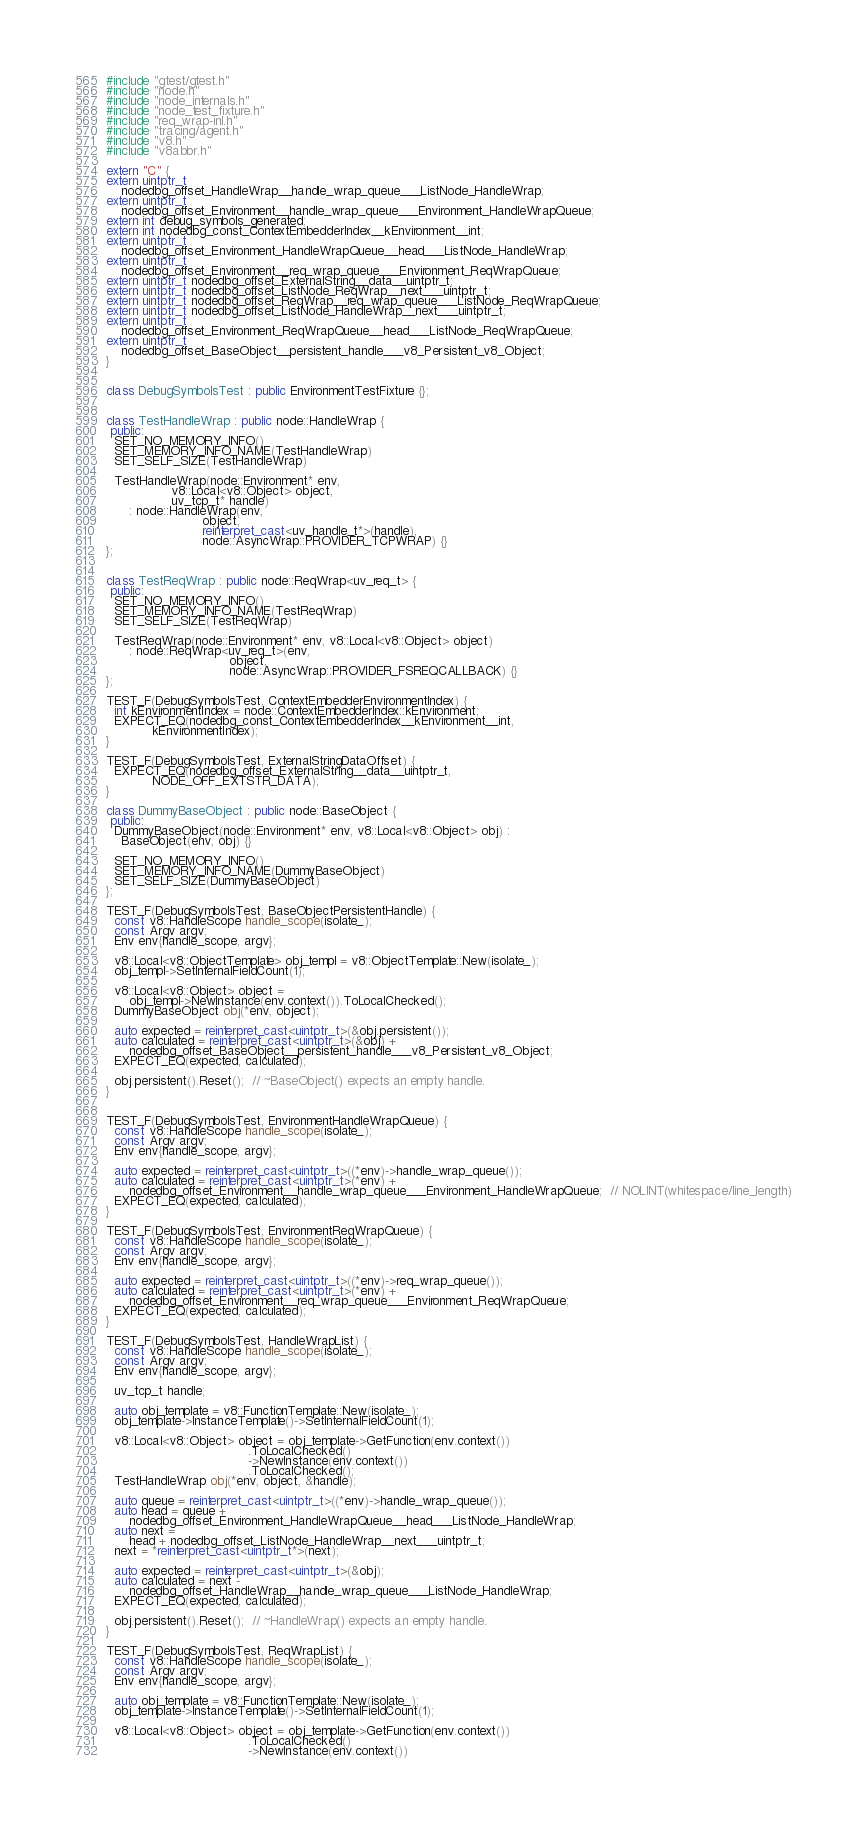Convert code to text. <code><loc_0><loc_0><loc_500><loc_500><_C++_>#include "gtest/gtest.h"
#include "node.h"
#include "node_internals.h"
#include "node_test_fixture.h"
#include "req_wrap-inl.h"
#include "tracing/agent.h"
#include "v8.h"
#include "v8abbr.h"

extern "C" {
extern uintptr_t
    nodedbg_offset_HandleWrap__handle_wrap_queue___ListNode_HandleWrap;
extern uintptr_t
    nodedbg_offset_Environment__handle_wrap_queue___Environment_HandleWrapQueue;
extern int debug_symbols_generated;
extern int nodedbg_const_ContextEmbedderIndex__kEnvironment__int;
extern uintptr_t
    nodedbg_offset_Environment_HandleWrapQueue__head___ListNode_HandleWrap;
extern uintptr_t
    nodedbg_offset_Environment__req_wrap_queue___Environment_ReqWrapQueue;
extern uintptr_t nodedbg_offset_ExternalString__data__uintptr_t;
extern uintptr_t nodedbg_offset_ListNode_ReqWrap__next___uintptr_t;
extern uintptr_t nodedbg_offset_ReqWrap__req_wrap_queue___ListNode_ReqWrapQueue;
extern uintptr_t nodedbg_offset_ListNode_HandleWrap__next___uintptr_t;
extern uintptr_t
    nodedbg_offset_Environment_ReqWrapQueue__head___ListNode_ReqWrapQueue;
extern uintptr_t
    nodedbg_offset_BaseObject__persistent_handle___v8_Persistent_v8_Object;
}


class DebugSymbolsTest : public EnvironmentTestFixture {};


class TestHandleWrap : public node::HandleWrap {
 public:
  SET_NO_MEMORY_INFO()
  SET_MEMORY_INFO_NAME(TestHandleWrap)
  SET_SELF_SIZE(TestHandleWrap)

  TestHandleWrap(node::Environment* env,
                 v8::Local<v8::Object> object,
                 uv_tcp_t* handle)
      : node::HandleWrap(env,
                         object,
                         reinterpret_cast<uv_handle_t*>(handle),
                         node::AsyncWrap::PROVIDER_TCPWRAP) {}
};


class TestReqWrap : public node::ReqWrap<uv_req_t> {
 public:
  SET_NO_MEMORY_INFO()
  SET_MEMORY_INFO_NAME(TestReqWrap)
  SET_SELF_SIZE(TestReqWrap)

  TestReqWrap(node::Environment* env, v8::Local<v8::Object> object)
      : node::ReqWrap<uv_req_t>(env,
                                object,
                                node::AsyncWrap::PROVIDER_FSREQCALLBACK) {}
};

TEST_F(DebugSymbolsTest, ContextEmbedderEnvironmentIndex) {
  int kEnvironmentIndex = node::ContextEmbedderIndex::kEnvironment;
  EXPECT_EQ(nodedbg_const_ContextEmbedderIndex__kEnvironment__int,
            kEnvironmentIndex);
}

TEST_F(DebugSymbolsTest, ExternalStringDataOffset) {
  EXPECT_EQ(nodedbg_offset_ExternalString__data__uintptr_t,
            NODE_OFF_EXTSTR_DATA);
}

class DummyBaseObject : public node::BaseObject {
 public:
  DummyBaseObject(node::Environment* env, v8::Local<v8::Object> obj) :
    BaseObject(env, obj) {}

  SET_NO_MEMORY_INFO()
  SET_MEMORY_INFO_NAME(DummyBaseObject)
  SET_SELF_SIZE(DummyBaseObject)
};

TEST_F(DebugSymbolsTest, BaseObjectPersistentHandle) {
  const v8::HandleScope handle_scope(isolate_);
  const Argv argv;
  Env env{handle_scope, argv};

  v8::Local<v8::ObjectTemplate> obj_templ = v8::ObjectTemplate::New(isolate_);
  obj_templ->SetInternalFieldCount(1);

  v8::Local<v8::Object> object =
      obj_templ->NewInstance(env.context()).ToLocalChecked();
  DummyBaseObject obj(*env, object);

  auto expected = reinterpret_cast<uintptr_t>(&obj.persistent());
  auto calculated = reinterpret_cast<uintptr_t>(&obj) +
      nodedbg_offset_BaseObject__persistent_handle___v8_Persistent_v8_Object;
  EXPECT_EQ(expected, calculated);

  obj.persistent().Reset();  // ~BaseObject() expects an empty handle.
}


TEST_F(DebugSymbolsTest, EnvironmentHandleWrapQueue) {
  const v8::HandleScope handle_scope(isolate_);
  const Argv argv;
  Env env{handle_scope, argv};

  auto expected = reinterpret_cast<uintptr_t>((*env)->handle_wrap_queue());
  auto calculated = reinterpret_cast<uintptr_t>(*env) +
      nodedbg_offset_Environment__handle_wrap_queue___Environment_HandleWrapQueue;  // NOLINT(whitespace/line_length)
  EXPECT_EQ(expected, calculated);
}

TEST_F(DebugSymbolsTest, EnvironmentReqWrapQueue) {
  const v8::HandleScope handle_scope(isolate_);
  const Argv argv;
  Env env{handle_scope, argv};

  auto expected = reinterpret_cast<uintptr_t>((*env)->req_wrap_queue());
  auto calculated = reinterpret_cast<uintptr_t>(*env) +
      nodedbg_offset_Environment__req_wrap_queue___Environment_ReqWrapQueue;
  EXPECT_EQ(expected, calculated);
}

TEST_F(DebugSymbolsTest, HandleWrapList) {
  const v8::HandleScope handle_scope(isolate_);
  const Argv argv;
  Env env{handle_scope, argv};

  uv_tcp_t handle;

  auto obj_template = v8::FunctionTemplate::New(isolate_);
  obj_template->InstanceTemplate()->SetInternalFieldCount(1);

  v8::Local<v8::Object> object = obj_template->GetFunction(env.context())
                                     .ToLocalChecked()
                                     ->NewInstance(env.context())
                                     .ToLocalChecked();
  TestHandleWrap obj(*env, object, &handle);

  auto queue = reinterpret_cast<uintptr_t>((*env)->handle_wrap_queue());
  auto head = queue +
      nodedbg_offset_Environment_HandleWrapQueue__head___ListNode_HandleWrap;
  auto next =
      head + nodedbg_offset_ListNode_HandleWrap__next___uintptr_t;
  next = *reinterpret_cast<uintptr_t*>(next);

  auto expected = reinterpret_cast<uintptr_t>(&obj);
  auto calculated = next -
      nodedbg_offset_HandleWrap__handle_wrap_queue___ListNode_HandleWrap;
  EXPECT_EQ(expected, calculated);

  obj.persistent().Reset();  // ~HandleWrap() expects an empty handle.
}

TEST_F(DebugSymbolsTest, ReqWrapList) {
  const v8::HandleScope handle_scope(isolate_);
  const Argv argv;
  Env env{handle_scope, argv};

  auto obj_template = v8::FunctionTemplate::New(isolate_);
  obj_template->InstanceTemplate()->SetInternalFieldCount(1);

  v8::Local<v8::Object> object = obj_template->GetFunction(env.context())
                                     .ToLocalChecked()
                                     ->NewInstance(env.context())</code> 